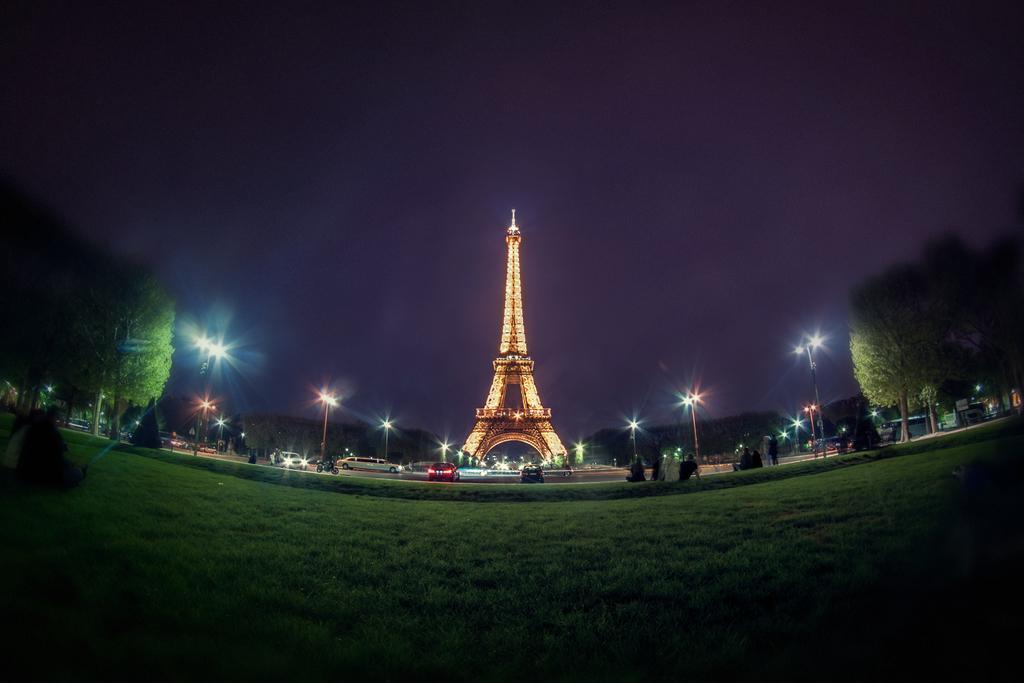How would you summarize this image in a sentence or two? This is an image clicked in the dark. At the bottom of the image I can see the grass. In the background there are trees, vehicles on the road, street lights and a tower. At the top I can see the sky. 